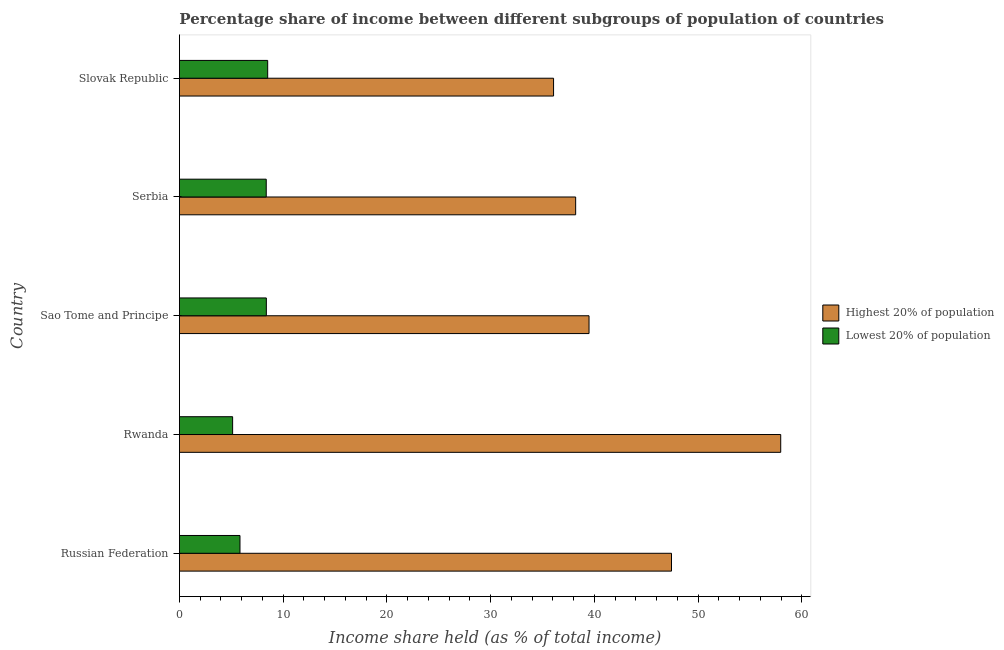Are the number of bars per tick equal to the number of legend labels?
Keep it short and to the point. Yes. Are the number of bars on each tick of the Y-axis equal?
Offer a very short reply. Yes. How many bars are there on the 1st tick from the top?
Your answer should be compact. 2. What is the label of the 4th group of bars from the top?
Offer a very short reply. Rwanda. What is the income share held by highest 20% of the population in Serbia?
Your answer should be very brief. 38.2. Across all countries, what is the maximum income share held by lowest 20% of the population?
Provide a succinct answer. 8.51. Across all countries, what is the minimum income share held by highest 20% of the population?
Make the answer very short. 36.07. In which country was the income share held by highest 20% of the population maximum?
Give a very brief answer. Rwanda. In which country was the income share held by highest 20% of the population minimum?
Your answer should be compact. Slovak Republic. What is the total income share held by highest 20% of the population in the graph?
Provide a succinct answer. 219.17. What is the difference between the income share held by highest 20% of the population in Russian Federation and that in Serbia?
Your response must be concise. 9.24. What is the difference between the income share held by highest 20% of the population in Slovak Republic and the income share held by lowest 20% of the population in Russian Federation?
Ensure brevity in your answer.  30.23. What is the average income share held by highest 20% of the population per country?
Offer a terse response. 43.83. What is the difference between the income share held by highest 20% of the population and income share held by lowest 20% of the population in Serbia?
Your answer should be compact. 29.83. What is the ratio of the income share held by highest 20% of the population in Sao Tome and Principe to that in Serbia?
Your response must be concise. 1.03. What is the difference between the highest and the second highest income share held by lowest 20% of the population?
Make the answer very short. 0.13. What is the difference between the highest and the lowest income share held by highest 20% of the population?
Your response must be concise. 21.9. What does the 1st bar from the top in Rwanda represents?
Offer a very short reply. Lowest 20% of population. What does the 1st bar from the bottom in Slovak Republic represents?
Provide a succinct answer. Highest 20% of population. How many bars are there?
Give a very brief answer. 10. Are all the bars in the graph horizontal?
Make the answer very short. Yes. Are the values on the major ticks of X-axis written in scientific E-notation?
Your answer should be very brief. No. Does the graph contain any zero values?
Your response must be concise. No. Where does the legend appear in the graph?
Your answer should be very brief. Center right. What is the title of the graph?
Keep it short and to the point. Percentage share of income between different subgroups of population of countries. What is the label or title of the X-axis?
Provide a succinct answer. Income share held (as % of total income). What is the label or title of the Y-axis?
Provide a short and direct response. Country. What is the Income share held (as % of total income) in Highest 20% of population in Russian Federation?
Provide a succinct answer. 47.44. What is the Income share held (as % of total income) of Lowest 20% of population in Russian Federation?
Ensure brevity in your answer.  5.84. What is the Income share held (as % of total income) in Highest 20% of population in Rwanda?
Provide a succinct answer. 57.97. What is the Income share held (as % of total income) of Lowest 20% of population in Rwanda?
Offer a terse response. 5.13. What is the Income share held (as % of total income) in Highest 20% of population in Sao Tome and Principe?
Ensure brevity in your answer.  39.49. What is the Income share held (as % of total income) in Lowest 20% of population in Sao Tome and Principe?
Make the answer very short. 8.38. What is the Income share held (as % of total income) in Highest 20% of population in Serbia?
Offer a very short reply. 38.2. What is the Income share held (as % of total income) in Lowest 20% of population in Serbia?
Your answer should be very brief. 8.37. What is the Income share held (as % of total income) in Highest 20% of population in Slovak Republic?
Give a very brief answer. 36.07. What is the Income share held (as % of total income) of Lowest 20% of population in Slovak Republic?
Your response must be concise. 8.51. Across all countries, what is the maximum Income share held (as % of total income) of Highest 20% of population?
Your answer should be compact. 57.97. Across all countries, what is the maximum Income share held (as % of total income) in Lowest 20% of population?
Make the answer very short. 8.51. Across all countries, what is the minimum Income share held (as % of total income) in Highest 20% of population?
Make the answer very short. 36.07. Across all countries, what is the minimum Income share held (as % of total income) of Lowest 20% of population?
Offer a terse response. 5.13. What is the total Income share held (as % of total income) of Highest 20% of population in the graph?
Provide a succinct answer. 219.17. What is the total Income share held (as % of total income) of Lowest 20% of population in the graph?
Provide a succinct answer. 36.23. What is the difference between the Income share held (as % of total income) in Highest 20% of population in Russian Federation and that in Rwanda?
Make the answer very short. -10.53. What is the difference between the Income share held (as % of total income) in Lowest 20% of population in Russian Federation and that in Rwanda?
Your answer should be very brief. 0.71. What is the difference between the Income share held (as % of total income) in Highest 20% of population in Russian Federation and that in Sao Tome and Principe?
Provide a short and direct response. 7.95. What is the difference between the Income share held (as % of total income) of Lowest 20% of population in Russian Federation and that in Sao Tome and Principe?
Ensure brevity in your answer.  -2.54. What is the difference between the Income share held (as % of total income) in Highest 20% of population in Russian Federation and that in Serbia?
Provide a succinct answer. 9.24. What is the difference between the Income share held (as % of total income) of Lowest 20% of population in Russian Federation and that in Serbia?
Your response must be concise. -2.53. What is the difference between the Income share held (as % of total income) in Highest 20% of population in Russian Federation and that in Slovak Republic?
Offer a terse response. 11.37. What is the difference between the Income share held (as % of total income) in Lowest 20% of population in Russian Federation and that in Slovak Republic?
Your response must be concise. -2.67. What is the difference between the Income share held (as % of total income) of Highest 20% of population in Rwanda and that in Sao Tome and Principe?
Provide a succinct answer. 18.48. What is the difference between the Income share held (as % of total income) in Lowest 20% of population in Rwanda and that in Sao Tome and Principe?
Ensure brevity in your answer.  -3.25. What is the difference between the Income share held (as % of total income) in Highest 20% of population in Rwanda and that in Serbia?
Make the answer very short. 19.77. What is the difference between the Income share held (as % of total income) of Lowest 20% of population in Rwanda and that in Serbia?
Keep it short and to the point. -3.24. What is the difference between the Income share held (as % of total income) in Highest 20% of population in Rwanda and that in Slovak Republic?
Ensure brevity in your answer.  21.9. What is the difference between the Income share held (as % of total income) of Lowest 20% of population in Rwanda and that in Slovak Republic?
Offer a terse response. -3.38. What is the difference between the Income share held (as % of total income) in Highest 20% of population in Sao Tome and Principe and that in Serbia?
Your response must be concise. 1.29. What is the difference between the Income share held (as % of total income) of Lowest 20% of population in Sao Tome and Principe and that in Serbia?
Offer a terse response. 0.01. What is the difference between the Income share held (as % of total income) of Highest 20% of population in Sao Tome and Principe and that in Slovak Republic?
Your answer should be compact. 3.42. What is the difference between the Income share held (as % of total income) of Lowest 20% of population in Sao Tome and Principe and that in Slovak Republic?
Your answer should be very brief. -0.13. What is the difference between the Income share held (as % of total income) in Highest 20% of population in Serbia and that in Slovak Republic?
Keep it short and to the point. 2.13. What is the difference between the Income share held (as % of total income) of Lowest 20% of population in Serbia and that in Slovak Republic?
Give a very brief answer. -0.14. What is the difference between the Income share held (as % of total income) in Highest 20% of population in Russian Federation and the Income share held (as % of total income) in Lowest 20% of population in Rwanda?
Offer a very short reply. 42.31. What is the difference between the Income share held (as % of total income) in Highest 20% of population in Russian Federation and the Income share held (as % of total income) in Lowest 20% of population in Sao Tome and Principe?
Offer a terse response. 39.06. What is the difference between the Income share held (as % of total income) of Highest 20% of population in Russian Federation and the Income share held (as % of total income) of Lowest 20% of population in Serbia?
Ensure brevity in your answer.  39.07. What is the difference between the Income share held (as % of total income) in Highest 20% of population in Russian Federation and the Income share held (as % of total income) in Lowest 20% of population in Slovak Republic?
Offer a very short reply. 38.93. What is the difference between the Income share held (as % of total income) in Highest 20% of population in Rwanda and the Income share held (as % of total income) in Lowest 20% of population in Sao Tome and Principe?
Your answer should be very brief. 49.59. What is the difference between the Income share held (as % of total income) in Highest 20% of population in Rwanda and the Income share held (as % of total income) in Lowest 20% of population in Serbia?
Make the answer very short. 49.6. What is the difference between the Income share held (as % of total income) in Highest 20% of population in Rwanda and the Income share held (as % of total income) in Lowest 20% of population in Slovak Republic?
Your response must be concise. 49.46. What is the difference between the Income share held (as % of total income) of Highest 20% of population in Sao Tome and Principe and the Income share held (as % of total income) of Lowest 20% of population in Serbia?
Keep it short and to the point. 31.12. What is the difference between the Income share held (as % of total income) of Highest 20% of population in Sao Tome and Principe and the Income share held (as % of total income) of Lowest 20% of population in Slovak Republic?
Provide a succinct answer. 30.98. What is the difference between the Income share held (as % of total income) of Highest 20% of population in Serbia and the Income share held (as % of total income) of Lowest 20% of population in Slovak Republic?
Give a very brief answer. 29.69. What is the average Income share held (as % of total income) of Highest 20% of population per country?
Make the answer very short. 43.83. What is the average Income share held (as % of total income) of Lowest 20% of population per country?
Provide a succinct answer. 7.25. What is the difference between the Income share held (as % of total income) of Highest 20% of population and Income share held (as % of total income) of Lowest 20% of population in Russian Federation?
Your answer should be very brief. 41.6. What is the difference between the Income share held (as % of total income) in Highest 20% of population and Income share held (as % of total income) in Lowest 20% of population in Rwanda?
Your response must be concise. 52.84. What is the difference between the Income share held (as % of total income) in Highest 20% of population and Income share held (as % of total income) in Lowest 20% of population in Sao Tome and Principe?
Offer a very short reply. 31.11. What is the difference between the Income share held (as % of total income) of Highest 20% of population and Income share held (as % of total income) of Lowest 20% of population in Serbia?
Make the answer very short. 29.83. What is the difference between the Income share held (as % of total income) in Highest 20% of population and Income share held (as % of total income) in Lowest 20% of population in Slovak Republic?
Keep it short and to the point. 27.56. What is the ratio of the Income share held (as % of total income) in Highest 20% of population in Russian Federation to that in Rwanda?
Provide a short and direct response. 0.82. What is the ratio of the Income share held (as % of total income) in Lowest 20% of population in Russian Federation to that in Rwanda?
Your answer should be very brief. 1.14. What is the ratio of the Income share held (as % of total income) of Highest 20% of population in Russian Federation to that in Sao Tome and Principe?
Ensure brevity in your answer.  1.2. What is the ratio of the Income share held (as % of total income) in Lowest 20% of population in Russian Federation to that in Sao Tome and Principe?
Ensure brevity in your answer.  0.7. What is the ratio of the Income share held (as % of total income) of Highest 20% of population in Russian Federation to that in Serbia?
Provide a short and direct response. 1.24. What is the ratio of the Income share held (as % of total income) in Lowest 20% of population in Russian Federation to that in Serbia?
Your response must be concise. 0.7. What is the ratio of the Income share held (as % of total income) in Highest 20% of population in Russian Federation to that in Slovak Republic?
Make the answer very short. 1.32. What is the ratio of the Income share held (as % of total income) in Lowest 20% of population in Russian Federation to that in Slovak Republic?
Give a very brief answer. 0.69. What is the ratio of the Income share held (as % of total income) of Highest 20% of population in Rwanda to that in Sao Tome and Principe?
Offer a very short reply. 1.47. What is the ratio of the Income share held (as % of total income) of Lowest 20% of population in Rwanda to that in Sao Tome and Principe?
Your answer should be compact. 0.61. What is the ratio of the Income share held (as % of total income) in Highest 20% of population in Rwanda to that in Serbia?
Offer a terse response. 1.52. What is the ratio of the Income share held (as % of total income) in Lowest 20% of population in Rwanda to that in Serbia?
Keep it short and to the point. 0.61. What is the ratio of the Income share held (as % of total income) in Highest 20% of population in Rwanda to that in Slovak Republic?
Keep it short and to the point. 1.61. What is the ratio of the Income share held (as % of total income) in Lowest 20% of population in Rwanda to that in Slovak Republic?
Provide a succinct answer. 0.6. What is the ratio of the Income share held (as % of total income) in Highest 20% of population in Sao Tome and Principe to that in Serbia?
Your answer should be very brief. 1.03. What is the ratio of the Income share held (as % of total income) in Lowest 20% of population in Sao Tome and Principe to that in Serbia?
Offer a terse response. 1. What is the ratio of the Income share held (as % of total income) in Highest 20% of population in Sao Tome and Principe to that in Slovak Republic?
Your answer should be compact. 1.09. What is the ratio of the Income share held (as % of total income) in Lowest 20% of population in Sao Tome and Principe to that in Slovak Republic?
Ensure brevity in your answer.  0.98. What is the ratio of the Income share held (as % of total income) in Highest 20% of population in Serbia to that in Slovak Republic?
Your response must be concise. 1.06. What is the ratio of the Income share held (as % of total income) in Lowest 20% of population in Serbia to that in Slovak Republic?
Give a very brief answer. 0.98. What is the difference between the highest and the second highest Income share held (as % of total income) of Highest 20% of population?
Give a very brief answer. 10.53. What is the difference between the highest and the second highest Income share held (as % of total income) of Lowest 20% of population?
Your answer should be compact. 0.13. What is the difference between the highest and the lowest Income share held (as % of total income) of Highest 20% of population?
Your response must be concise. 21.9. What is the difference between the highest and the lowest Income share held (as % of total income) of Lowest 20% of population?
Provide a succinct answer. 3.38. 